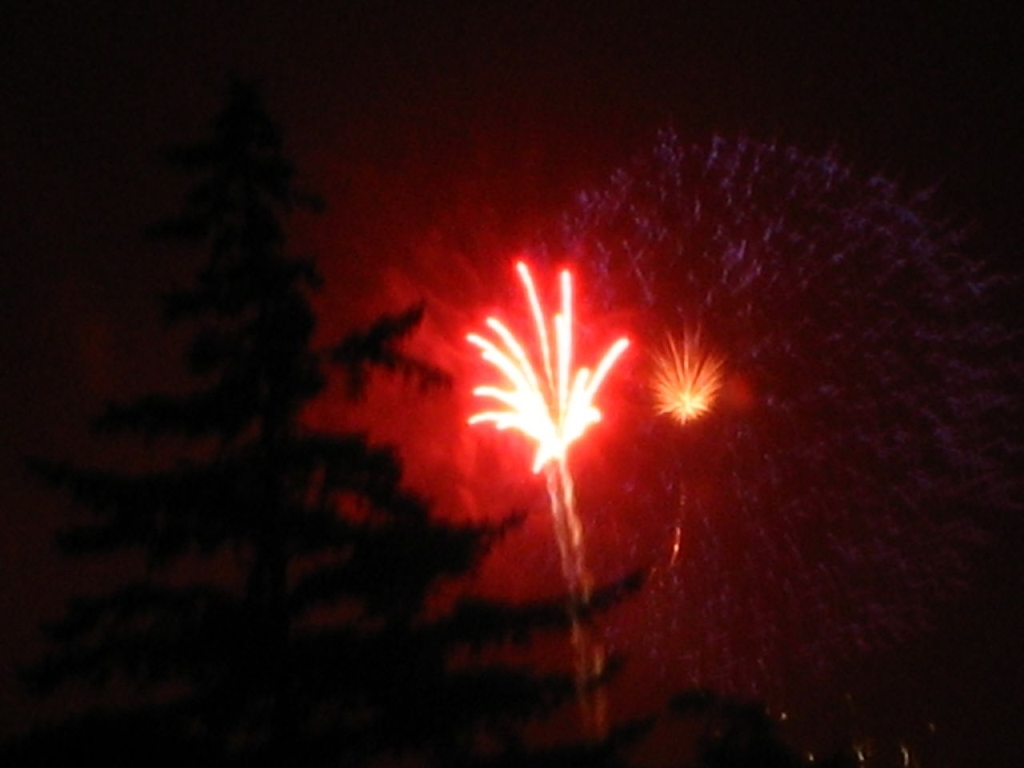What issues can be found in the image? A. Color balance issues B. Sharpness and focus issues C. Composition issues D. Noise and exposure issues Answer with the option's letter from the given choices directly. The main issue with the image appears to be related to sharpness and focus, as the fireworks and tree silhouettes are not clearly defined. There is also noticeable noise and some exposure issues, evidenced by the grainy texture and the overly bright areas contrasted with deep shadows. Hence, while 'D' for noise and exposure issues is partly correct, 'B' stands out as the more comprehensive choice, addressing the lack of clarity in detail. 